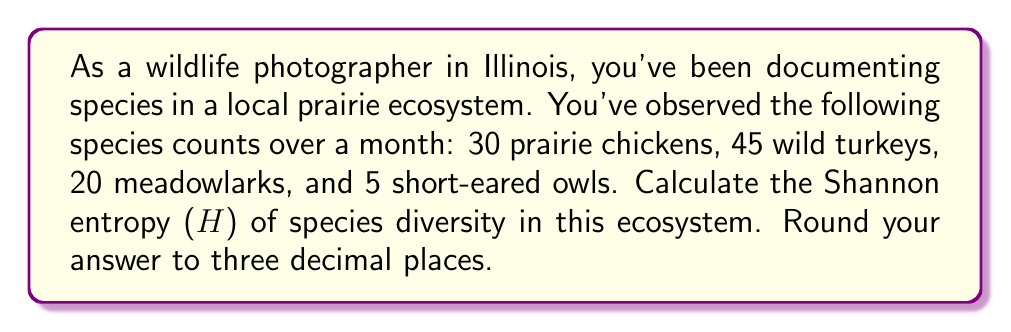Show me your answer to this math problem. To calculate the Shannon entropy (H) of species diversity, we'll use the formula:

$$ H = -\sum_{i=1}^{R} p_i \ln(p_i) $$

Where:
- $R$ is the number of species
- $p_i$ is the proportion of individuals belonging to the $i$-th species

Step 1: Calculate the total number of individuals
Total = 30 + 45 + 20 + 5 = 100

Step 2: Calculate the proportion ($p_i$) for each species
- Prairie chickens: $p_1 = 30/100 = 0.3$
- Wild turkeys: $p_2 = 45/100 = 0.45$
- Meadowlarks: $p_3 = 20/100 = 0.2$
- Short-eared owls: $p_4 = 5/100 = 0.05$

Step 3: Calculate $p_i \ln(p_i)$ for each species
- Prairie chickens: $0.3 \ln(0.3) \approx -0.3611$
- Wild turkeys: $0.45 \ln(0.45) \approx -0.3509$
- Meadowlarks: $0.2 \ln(0.2) \approx -0.3219$
- Short-eared owls: $0.05 \ln(0.05) \approx -0.1498$

Step 4: Sum the negative values
$H = -(-0.3611 - 0.3509 - 0.3219 - 0.1498)$

Step 5: Calculate the final result
$H = 1.1837$

Rounding to three decimal places: $H \approx 1.184$
Answer: The Shannon entropy (H) of species diversity in this ecosystem is approximately 1.184. 